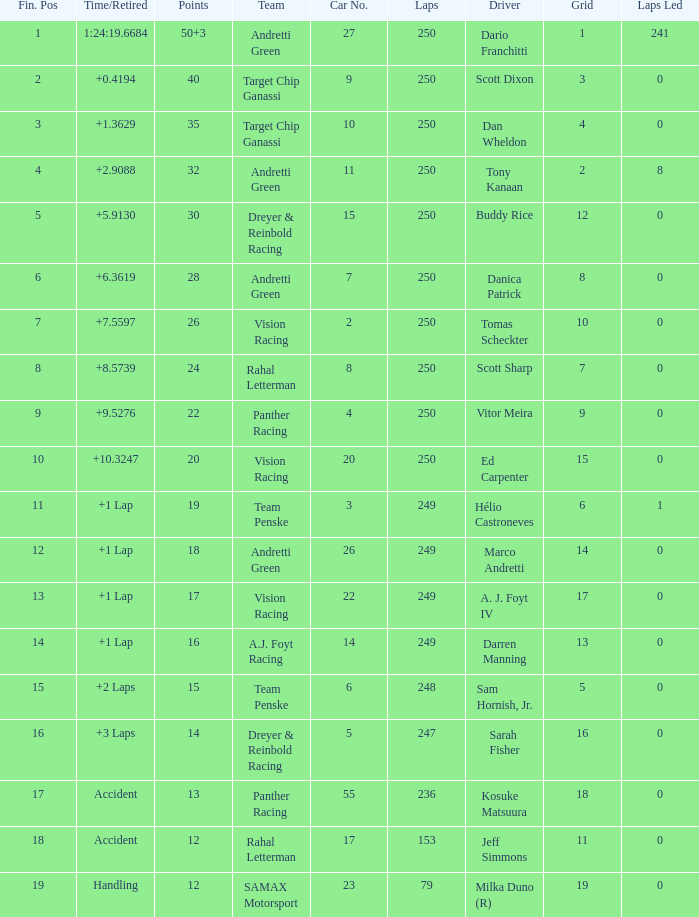Name the total number of fin pos for 12 points of accident 1.0. 